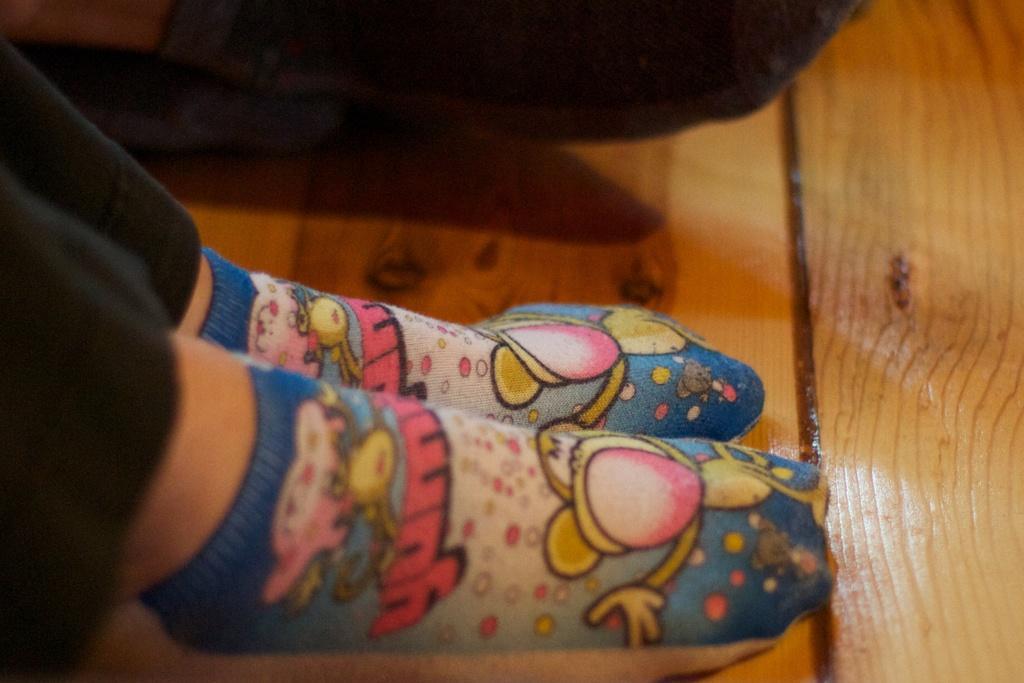Describe this image in one or two sentences. In this picture we can observe socks which are in blue and white color to the human legs. We can observe a black color pant. There is a wooden floor which is in brown color in the background. 